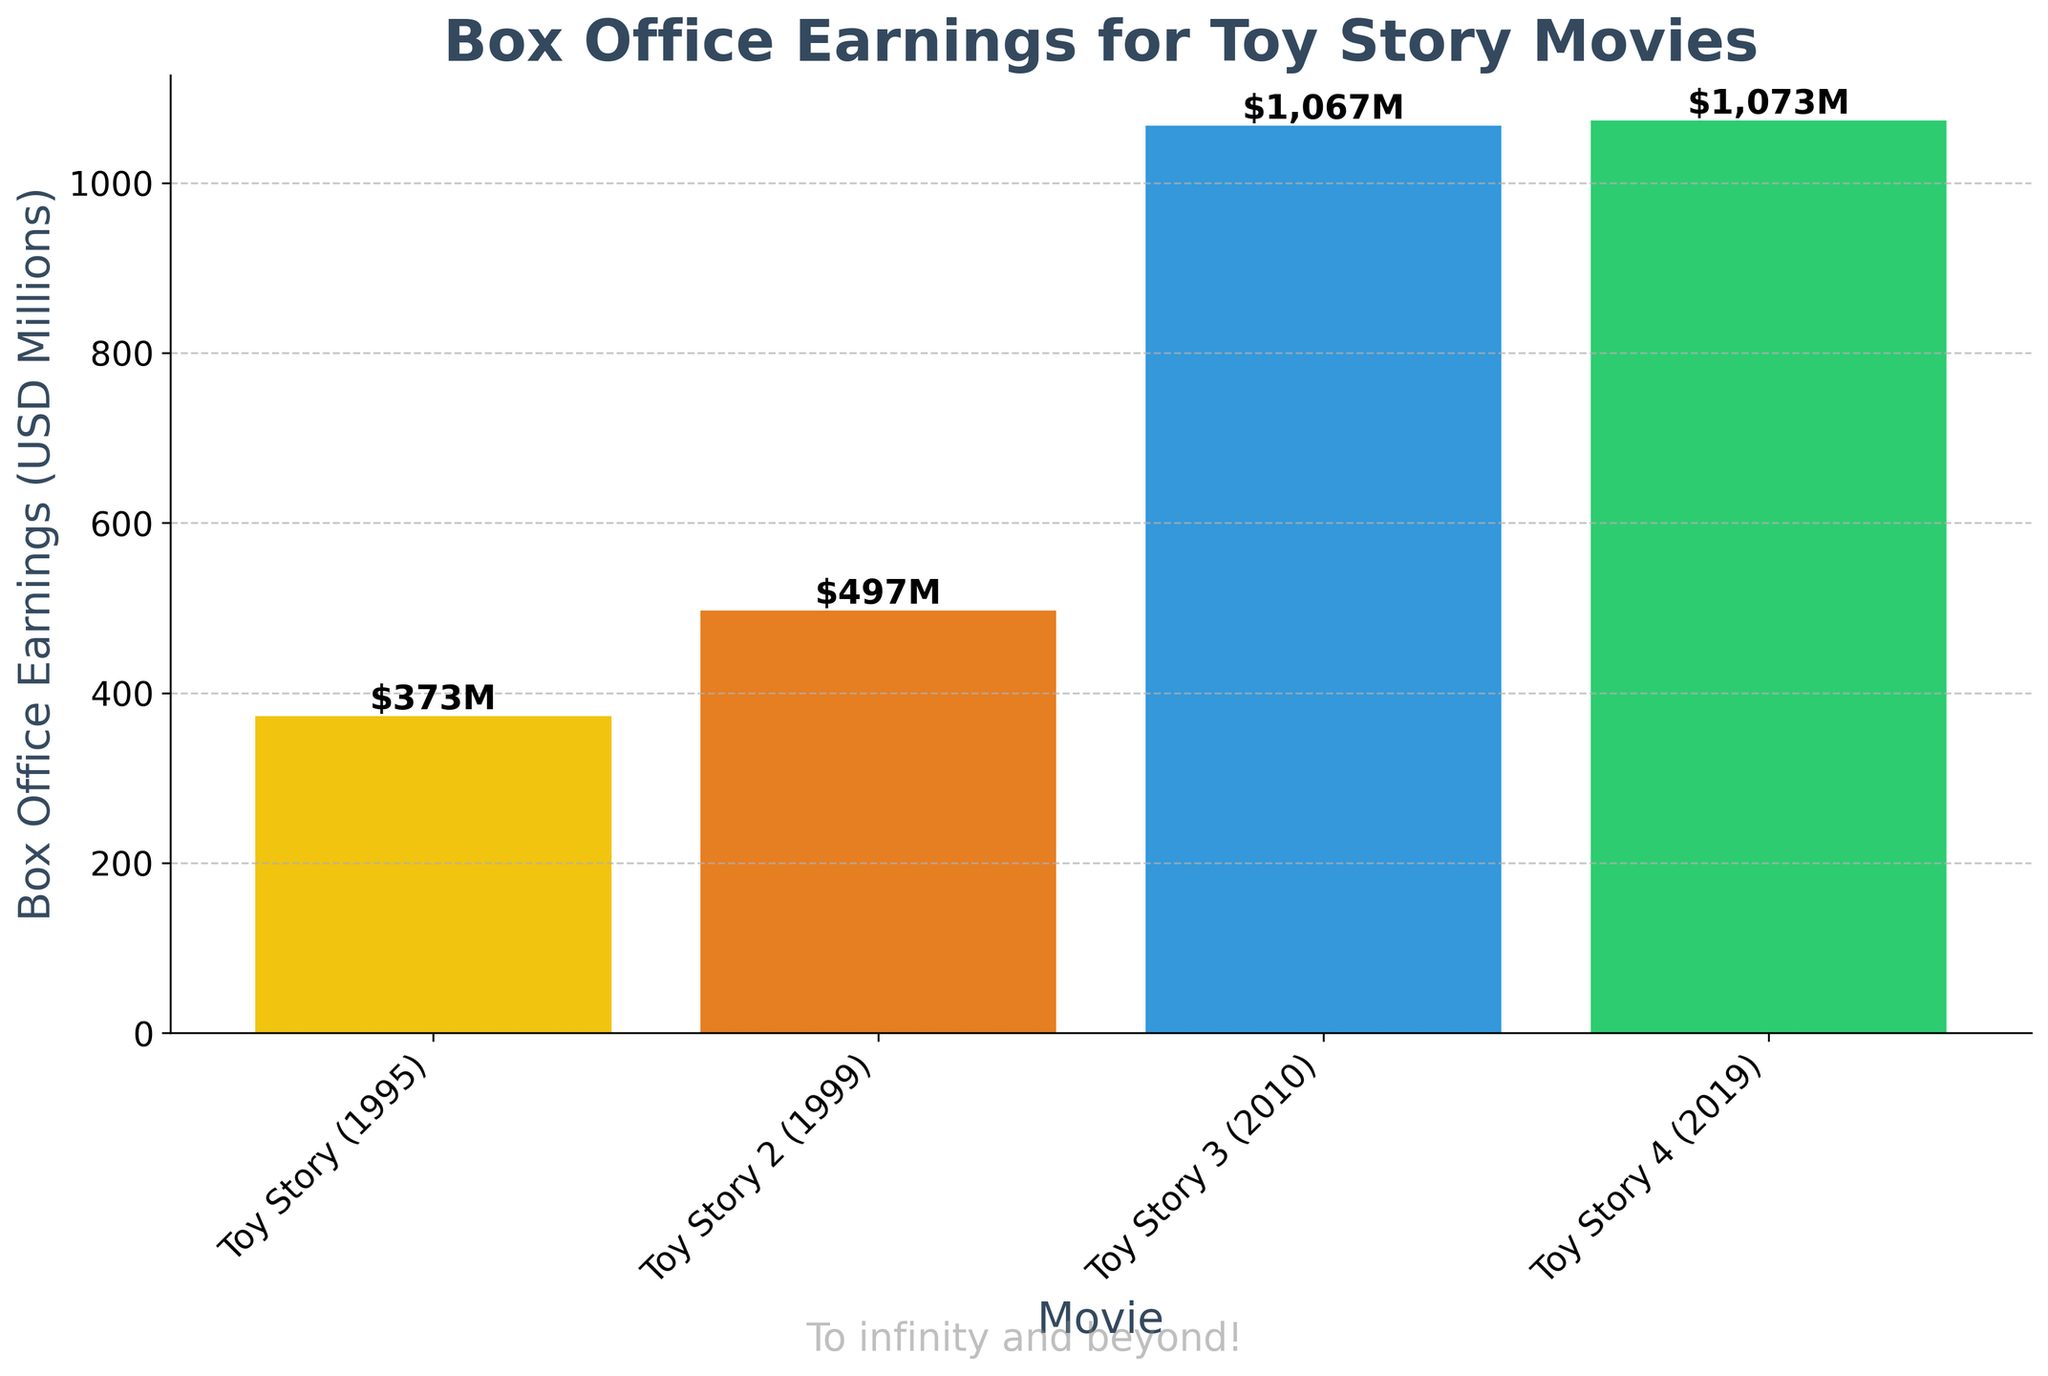What's the total box office earnings for all the movies combined? Sum of the earnings for each movie: $373M + $497M + $1067M + $1073M = $3010M
Answer: $3010M Which Toy Story movie had the highest box office earnings? The highest bar corresponds to "Toy Story 4" with $1073M earnings.
Answer: Toy Story 4 What is the difference in box office earnings between Toy Story (1995) and Toy Story 4? Difference is calculated by subtracting earnings of Toy Story (1995) from Toy Story 4: $1073M - $373M = $700M
Answer: $700M What is the average box office earnings of the movies shown on the chart? Total earnings are $3010M, divided by the number of movies (4): $3010M / 4 = $752.5M
Answer: $752.5M Which Toy Story movie earned more at the box office, Toy Story 2 or Toy Story 3? Comparing the heights of the bars, Toy Story 3 earned $1067M while Toy Story 2 earned $497M. Toy Story 3 earned more.
Answer: Toy Story 3 Rank the Toy Story movies from highest to lowest in terms of box office earnings. The earnings from highest to lowest are: Toy Story 4 ($1073M), Toy Story 3 ($1067M), Toy Story 2 ($497M), Toy Story ($373M)
Answer: Toy Story 4, Toy Story 3, Toy Story 2, Toy Story By how much did the box office earnings of Toy Story 2 exceed the original Toy Story (1995)? Difference is calculated by subtracting earnings of Toy Story (1995) from Toy Story 2: $497M - $373M = $124M
Answer: $124M How many more millions did Toy Story 4 make compared to Toy Story 3? Difference is calculated by subtracting the earnings of Toy Story 3 from Toy Story 4: $1073M - $1067M = $6M
Answer: $6M What color is the bar representing Toy Story 3? The color of Toy Story 3's bar is blue.
Answer: Blue Which movie has the shortest bar representing its box office earnings? The shortest bar represents Toy Story (1995) with $373M earnings.
Answer: Toy Story (1995) 